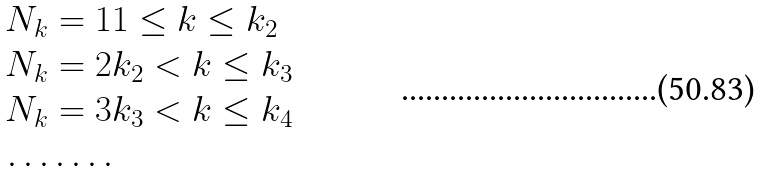Convert formula to latex. <formula><loc_0><loc_0><loc_500><loc_500>N _ { k } & = 1 1 \leq k \leq k _ { 2 } \\ N _ { k } & = 2 k _ { 2 } < k \leq k _ { 3 } \\ N _ { k } & = 3 k _ { 3 } < k \leq k _ { 4 } \\ \dots & \dots .</formula> 